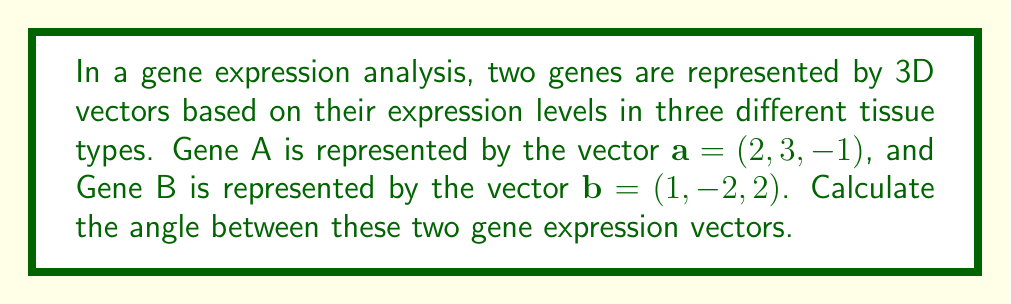Show me your answer to this math problem. To find the angle between two vectors in 3D space, we can use the dot product formula:

$$\cos \theta = \frac{\mathbf{a} \cdot \mathbf{b}}{|\mathbf{a}||\mathbf{b}|}$$

Where $\theta$ is the angle between the vectors, $\mathbf{a} \cdot \mathbf{b}$ is the dot product, and $|\mathbf{a}|$ and $|\mathbf{b}|$ are the magnitudes of vectors $\mathbf{a}$ and $\mathbf{b}$ respectively.

Step 1: Calculate the dot product $\mathbf{a} \cdot \mathbf{b}$
$$\mathbf{a} \cdot \mathbf{b} = (2)(1) + (3)(-2) + (-1)(2) = 2 - 6 - 2 = -6$$

Step 2: Calculate the magnitudes of $\mathbf{a}$ and $\mathbf{b}$
$$|\mathbf{a}| = \sqrt{2^2 + 3^2 + (-1)^2} = \sqrt{4 + 9 + 1} = \sqrt{14}$$
$$|\mathbf{b}| = \sqrt{1^2 + (-2)^2 + 2^2} = \sqrt{1 + 4 + 4} = 3$$

Step 3: Apply the dot product formula
$$\cos \theta = \frac{-6}{\sqrt{14} \cdot 3} = \frac{-6}{3\sqrt{14}}$$

Step 4: Take the inverse cosine (arccos) of both sides
$$\theta = \arccos\left(\frac{-6}{3\sqrt{14}}\right)$$

Step 5: Convert to degrees
$$\theta = \arccos\left(\frac{-6}{3\sqrt{14}}\right) \cdot \frac{180°}{\pi} \approx 119.74°$$
Answer: $119.74°$ 